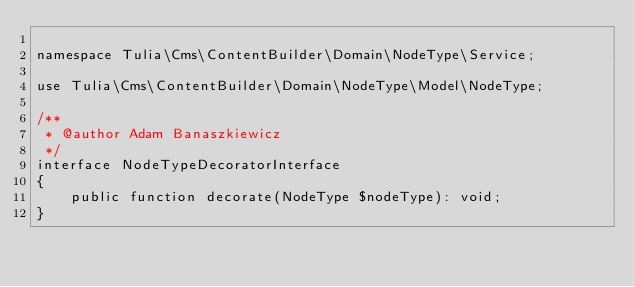Convert code to text. <code><loc_0><loc_0><loc_500><loc_500><_PHP_>
namespace Tulia\Cms\ContentBuilder\Domain\NodeType\Service;

use Tulia\Cms\ContentBuilder\Domain\NodeType\Model\NodeType;

/**
 * @author Adam Banaszkiewicz
 */
interface NodeTypeDecoratorInterface
{
    public function decorate(NodeType $nodeType): void;
}
</code> 